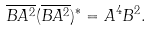Convert formula to latex. <formula><loc_0><loc_0><loc_500><loc_500>\overline { B A ^ { 2 } } ( \overline { B A ^ { 2 } } ) ^ { * } = A ^ { 4 } B ^ { 2 } .</formula> 